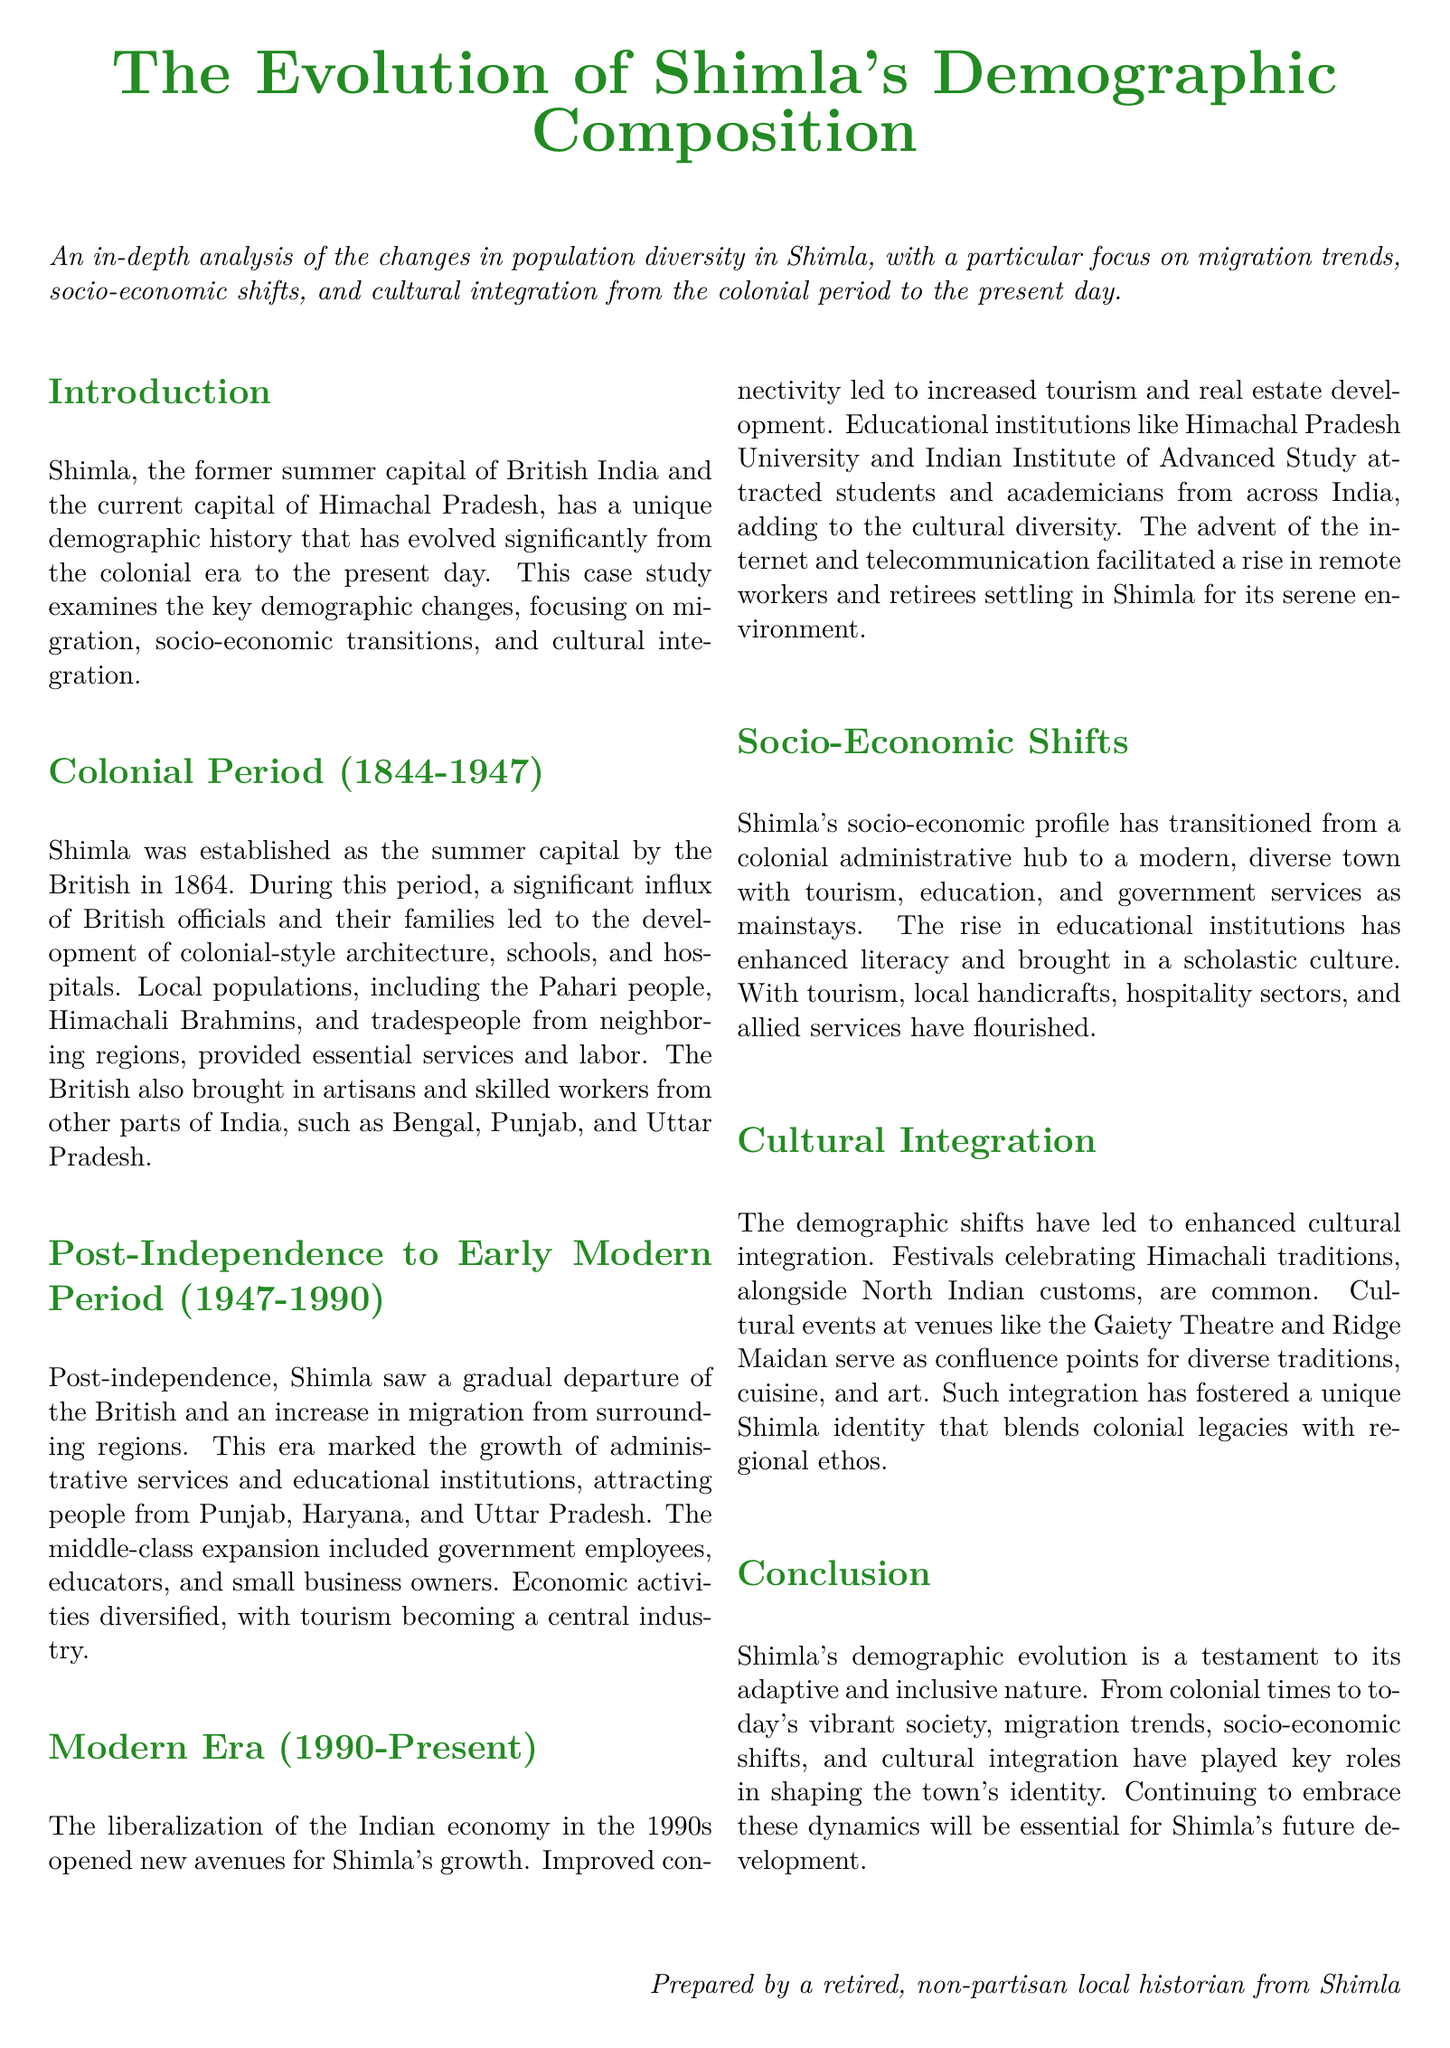What was established as Shimla's summer capital? The document states that Shimla was established as the summer capital by the British in 1864.
Answer: summer capital What workforce complemented the British officials during the colonial period? The local populations, including the Pahari people, Himachali Brahmins, and tradespeople from neighboring regions, provided essential services and labor.
Answer: local populations Which regions contributed to post-independence migration to Shimla? The document mentions that migration from Punjab, Haryana, and Uttar Pradesh increased after independence.
Answer: Punjab, Haryana, Uttar Pradesh What major industry developed in Shimla during the post-independence period? The document highlights that tourism became a central industry post-independence.
Answer: tourism What significant economic event occurred in the 1990s? The liberalization of the Indian economy in the 1990s opened new avenues for Shimla's growth.
Answer: liberalization Where is the cultural integration prominently displayed in Shimla? The document mentions that cultural events at venues like the Gaiety Theatre and Ridge Maidan serve as confluence points for diverse traditions.
Answer: Gaiety Theatre and Ridge Maidan How has Shimla's educational landscape changed since liberalization? The emergence of educational institutions like Himachal Pradesh University and Indian Institute of Advanced Study attracted students and academicians from across India.
Answer: educational institutions What is a key factor in Shimla's unique identity? Enhanced cultural integration alongside colonial legacies and regional ethos contributes to a unique identity.
Answer: cultural integration What period does the case study examine? The case study examines demographic changes from the colonial period to the present day.
Answer: colonial period to present day 